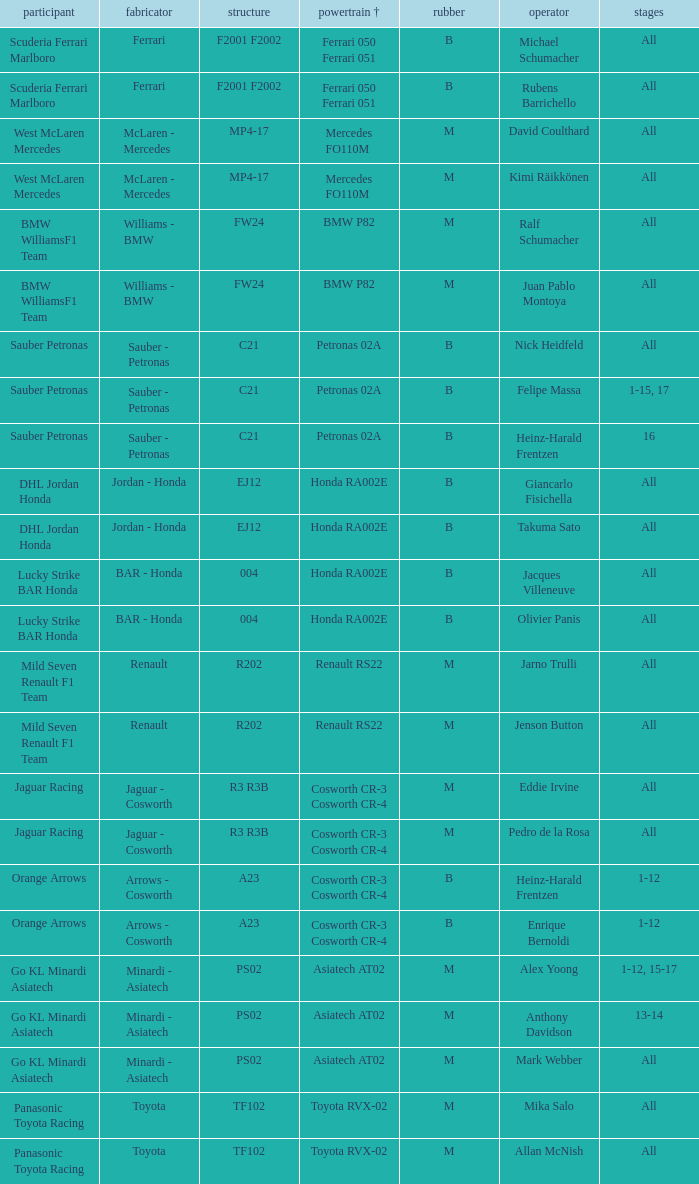Who is the entrant when the engine is bmw p82? BMW WilliamsF1 Team, BMW WilliamsF1 Team. Parse the table in full. {'header': ['participant', 'fabricator', 'structure', 'powertrain †', 'rubber', 'operator', 'stages'], 'rows': [['Scuderia Ferrari Marlboro', 'Ferrari', 'F2001 F2002', 'Ferrari 050 Ferrari 051', 'B', 'Michael Schumacher', 'All'], ['Scuderia Ferrari Marlboro', 'Ferrari', 'F2001 F2002', 'Ferrari 050 Ferrari 051', 'B', 'Rubens Barrichello', 'All'], ['West McLaren Mercedes', 'McLaren - Mercedes', 'MP4-17', 'Mercedes FO110M', 'M', 'David Coulthard', 'All'], ['West McLaren Mercedes', 'McLaren - Mercedes', 'MP4-17', 'Mercedes FO110M', 'M', 'Kimi Räikkönen', 'All'], ['BMW WilliamsF1 Team', 'Williams - BMW', 'FW24', 'BMW P82', 'M', 'Ralf Schumacher', 'All'], ['BMW WilliamsF1 Team', 'Williams - BMW', 'FW24', 'BMW P82', 'M', 'Juan Pablo Montoya', 'All'], ['Sauber Petronas', 'Sauber - Petronas', 'C21', 'Petronas 02A', 'B', 'Nick Heidfeld', 'All'], ['Sauber Petronas', 'Sauber - Petronas', 'C21', 'Petronas 02A', 'B', 'Felipe Massa', '1-15, 17'], ['Sauber Petronas', 'Sauber - Petronas', 'C21', 'Petronas 02A', 'B', 'Heinz-Harald Frentzen', '16'], ['DHL Jordan Honda', 'Jordan - Honda', 'EJ12', 'Honda RA002E', 'B', 'Giancarlo Fisichella', 'All'], ['DHL Jordan Honda', 'Jordan - Honda', 'EJ12', 'Honda RA002E', 'B', 'Takuma Sato', 'All'], ['Lucky Strike BAR Honda', 'BAR - Honda', '004', 'Honda RA002E', 'B', 'Jacques Villeneuve', 'All'], ['Lucky Strike BAR Honda', 'BAR - Honda', '004', 'Honda RA002E', 'B', 'Olivier Panis', 'All'], ['Mild Seven Renault F1 Team', 'Renault', 'R202', 'Renault RS22', 'M', 'Jarno Trulli', 'All'], ['Mild Seven Renault F1 Team', 'Renault', 'R202', 'Renault RS22', 'M', 'Jenson Button', 'All'], ['Jaguar Racing', 'Jaguar - Cosworth', 'R3 R3B', 'Cosworth CR-3 Cosworth CR-4', 'M', 'Eddie Irvine', 'All'], ['Jaguar Racing', 'Jaguar - Cosworth', 'R3 R3B', 'Cosworth CR-3 Cosworth CR-4', 'M', 'Pedro de la Rosa', 'All'], ['Orange Arrows', 'Arrows - Cosworth', 'A23', 'Cosworth CR-3 Cosworth CR-4', 'B', 'Heinz-Harald Frentzen', '1-12'], ['Orange Arrows', 'Arrows - Cosworth', 'A23', 'Cosworth CR-3 Cosworth CR-4', 'B', 'Enrique Bernoldi', '1-12'], ['Go KL Minardi Asiatech', 'Minardi - Asiatech', 'PS02', 'Asiatech AT02', 'M', 'Alex Yoong', '1-12, 15-17'], ['Go KL Minardi Asiatech', 'Minardi - Asiatech', 'PS02', 'Asiatech AT02', 'M', 'Anthony Davidson', '13-14'], ['Go KL Minardi Asiatech', 'Minardi - Asiatech', 'PS02', 'Asiatech AT02', 'M', 'Mark Webber', 'All'], ['Panasonic Toyota Racing', 'Toyota', 'TF102', 'Toyota RVX-02', 'M', 'Mika Salo', 'All'], ['Panasonic Toyota Racing', 'Toyota', 'TF102', 'Toyota RVX-02', 'M', 'Allan McNish', 'All']]} 